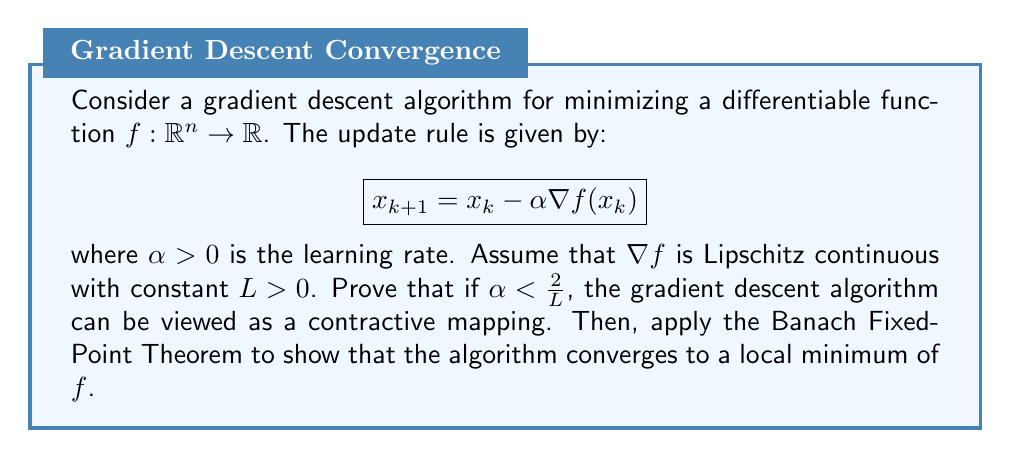Help me with this question. To prove that the gradient descent algorithm is a contractive mapping and apply the Banach Fixed-Point Theorem, we'll follow these steps:

1. Show that the update rule is a contractive mapping:
   Let $g(x) = x - \alpha \nabla f(x)$ be the mapping defined by the update rule.
   For any two points $x, y \in \mathbb{R}^n$, we need to show that $\|g(x) - g(y)\| \leq q\|x - y\|$ for some $q < 1$.

   $$\begin{align}
   \|g(x) - g(y)\| &= \|(x - \alpha \nabla f(x)) - (y - \alpha \nabla f(y))\| \\
   &= \|(x - y) - \alpha(\nabla f(x) - \nabla f(y))\| \\
   &\leq \|x - y\| + \alpha\|\nabla f(x) - \nabla f(y)\|
   \end{align}$$

   Using the Lipschitz continuity of $\nabla f$:

   $$\begin{align}
   \|g(x) - g(y)\| &\leq \|x - y\| + \alpha L\|x - y\| \\
   &= (1 + \alpha L)\|x - y\|
   \end{align}$$

   For $g$ to be a contraction, we need $1 + \alpha L < 1$, which implies $\alpha < \frac{2}{L}$.

2. Apply the Banach Fixed-Point Theorem:
   The Banach Fixed-Point Theorem states that if $g$ is a contraction mapping on a complete metric space, then it has a unique fixed point, and any sequence generated by iterating $g$ converges to that fixed point.

   In our case, $\mathbb{R}^n$ is a complete metric space, and we've shown that $g$ is a contraction when $\alpha < \frac{2}{L}$. Therefore, the gradient descent algorithm converges to a unique fixed point $x^*$.

3. Show that the fixed point is a local minimum:
   At the fixed point $x^*$, we have:

   $$x^* = g(x^*) = x^* - \alpha \nabla f(x^*)$$

   This implies that $\nabla f(x^*) = 0$, which is the necessary condition for $x^*$ to be a local minimum of $f$.

Thus, we've shown that the gradient descent algorithm converges to a local minimum of $f$ when $\alpha < \frac{2}{L}$.
Answer: The gradient descent algorithm converges to a local minimum of $f$ when $\alpha < \frac{2}{L}$. 